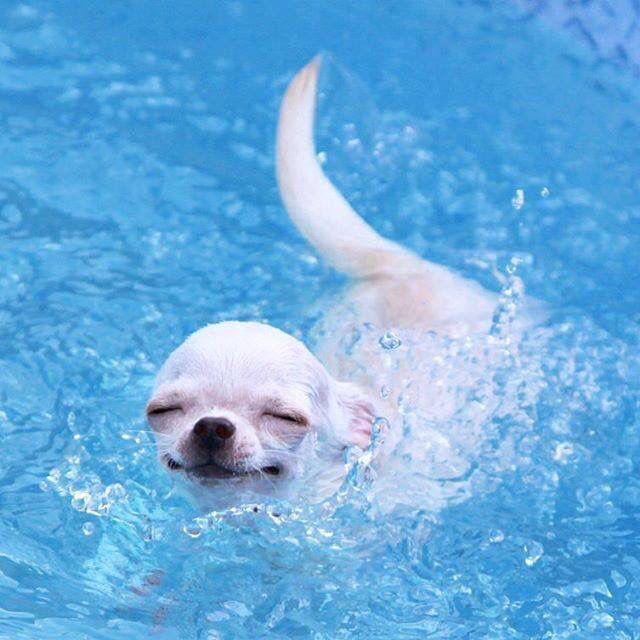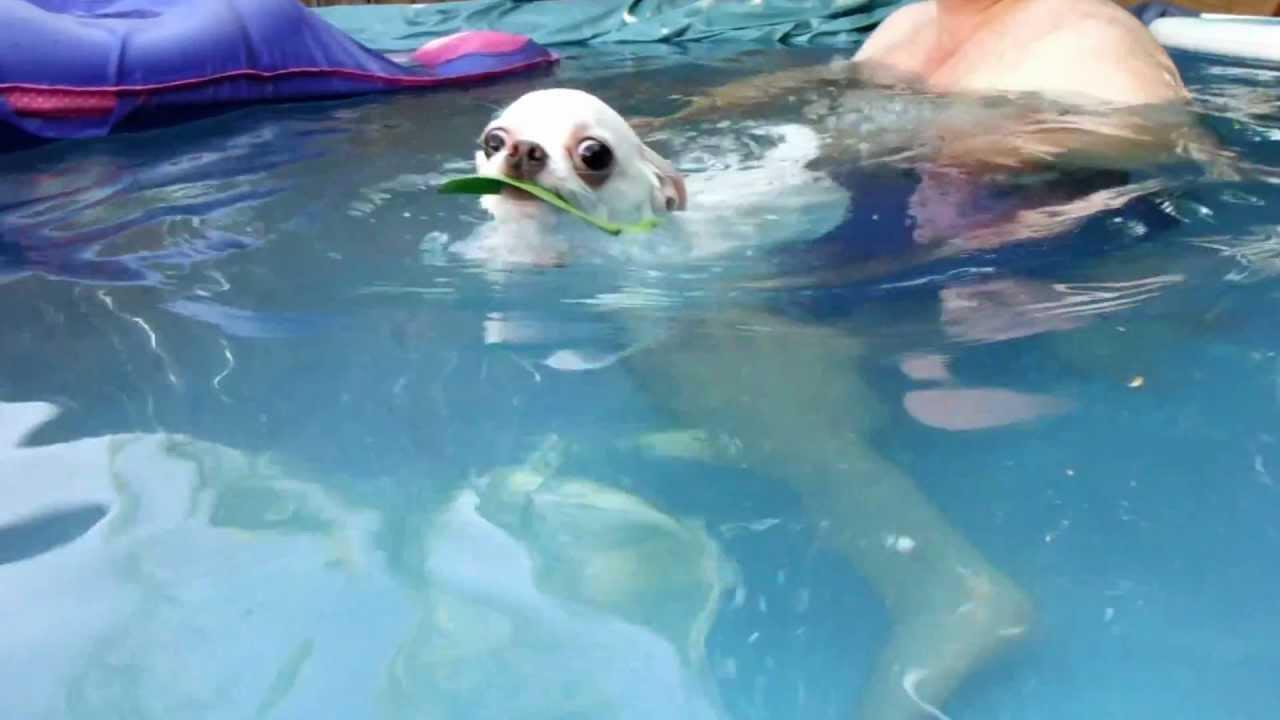The first image is the image on the left, the second image is the image on the right. Analyze the images presented: Is the assertion "There are two dogs in the pictures." valid? Answer yes or no. Yes. 